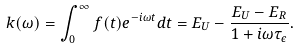<formula> <loc_0><loc_0><loc_500><loc_500>k ( \omega ) = \int _ { 0 } ^ { \infty } f ( t ) e ^ { - i \omega t } d t = E _ { U } - \frac { E _ { U } - E _ { R } } { 1 + i \omega \tau _ { \epsilon } } .</formula> 